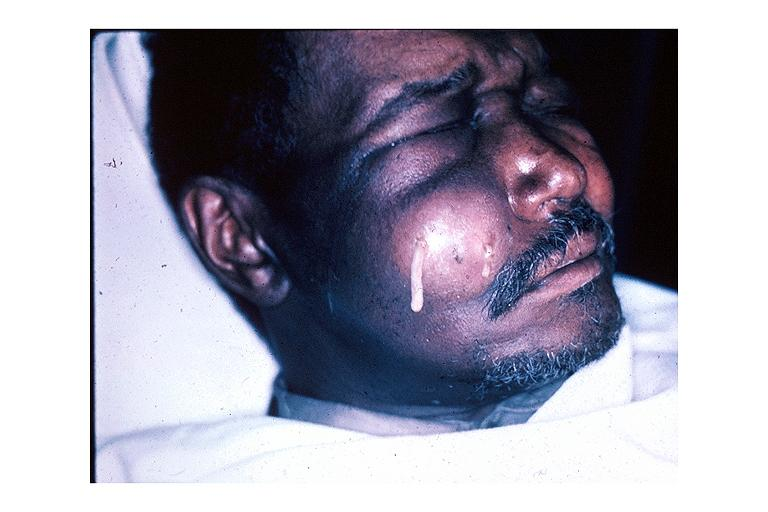where is this?
Answer the question using a single word or phrase. Oral 